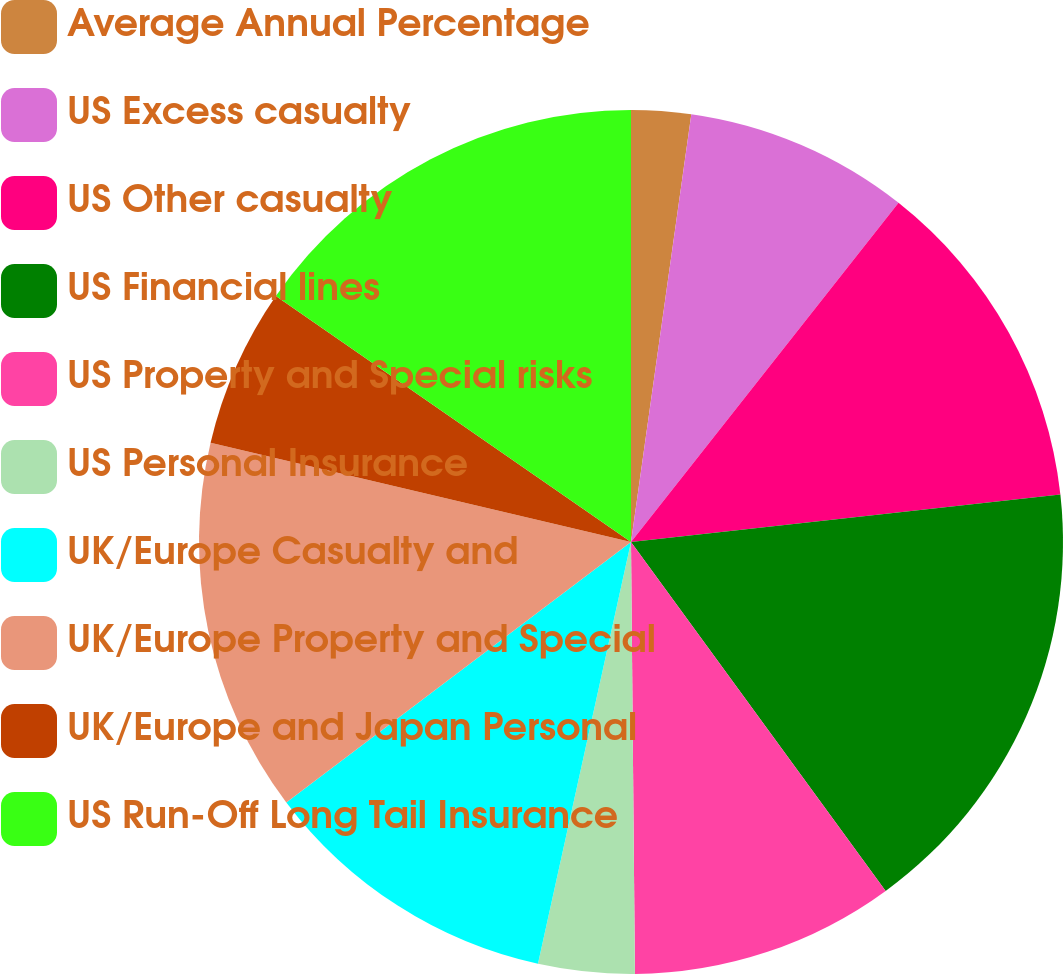Convert chart. <chart><loc_0><loc_0><loc_500><loc_500><pie_chart><fcel>Average Annual Percentage<fcel>US Excess casualty<fcel>US Other casualty<fcel>US Financial lines<fcel>US Property and Special risks<fcel>US Personal Insurance<fcel>UK/Europe Casualty and<fcel>UK/Europe Property and Special<fcel>UK/Europe and Japan Personal<fcel>US Run-Off Long Tail Insurance<nl><fcel>2.23%<fcel>8.4%<fcel>12.62%<fcel>16.72%<fcel>9.89%<fcel>3.6%<fcel>11.25%<fcel>13.99%<fcel>5.95%<fcel>15.36%<nl></chart> 